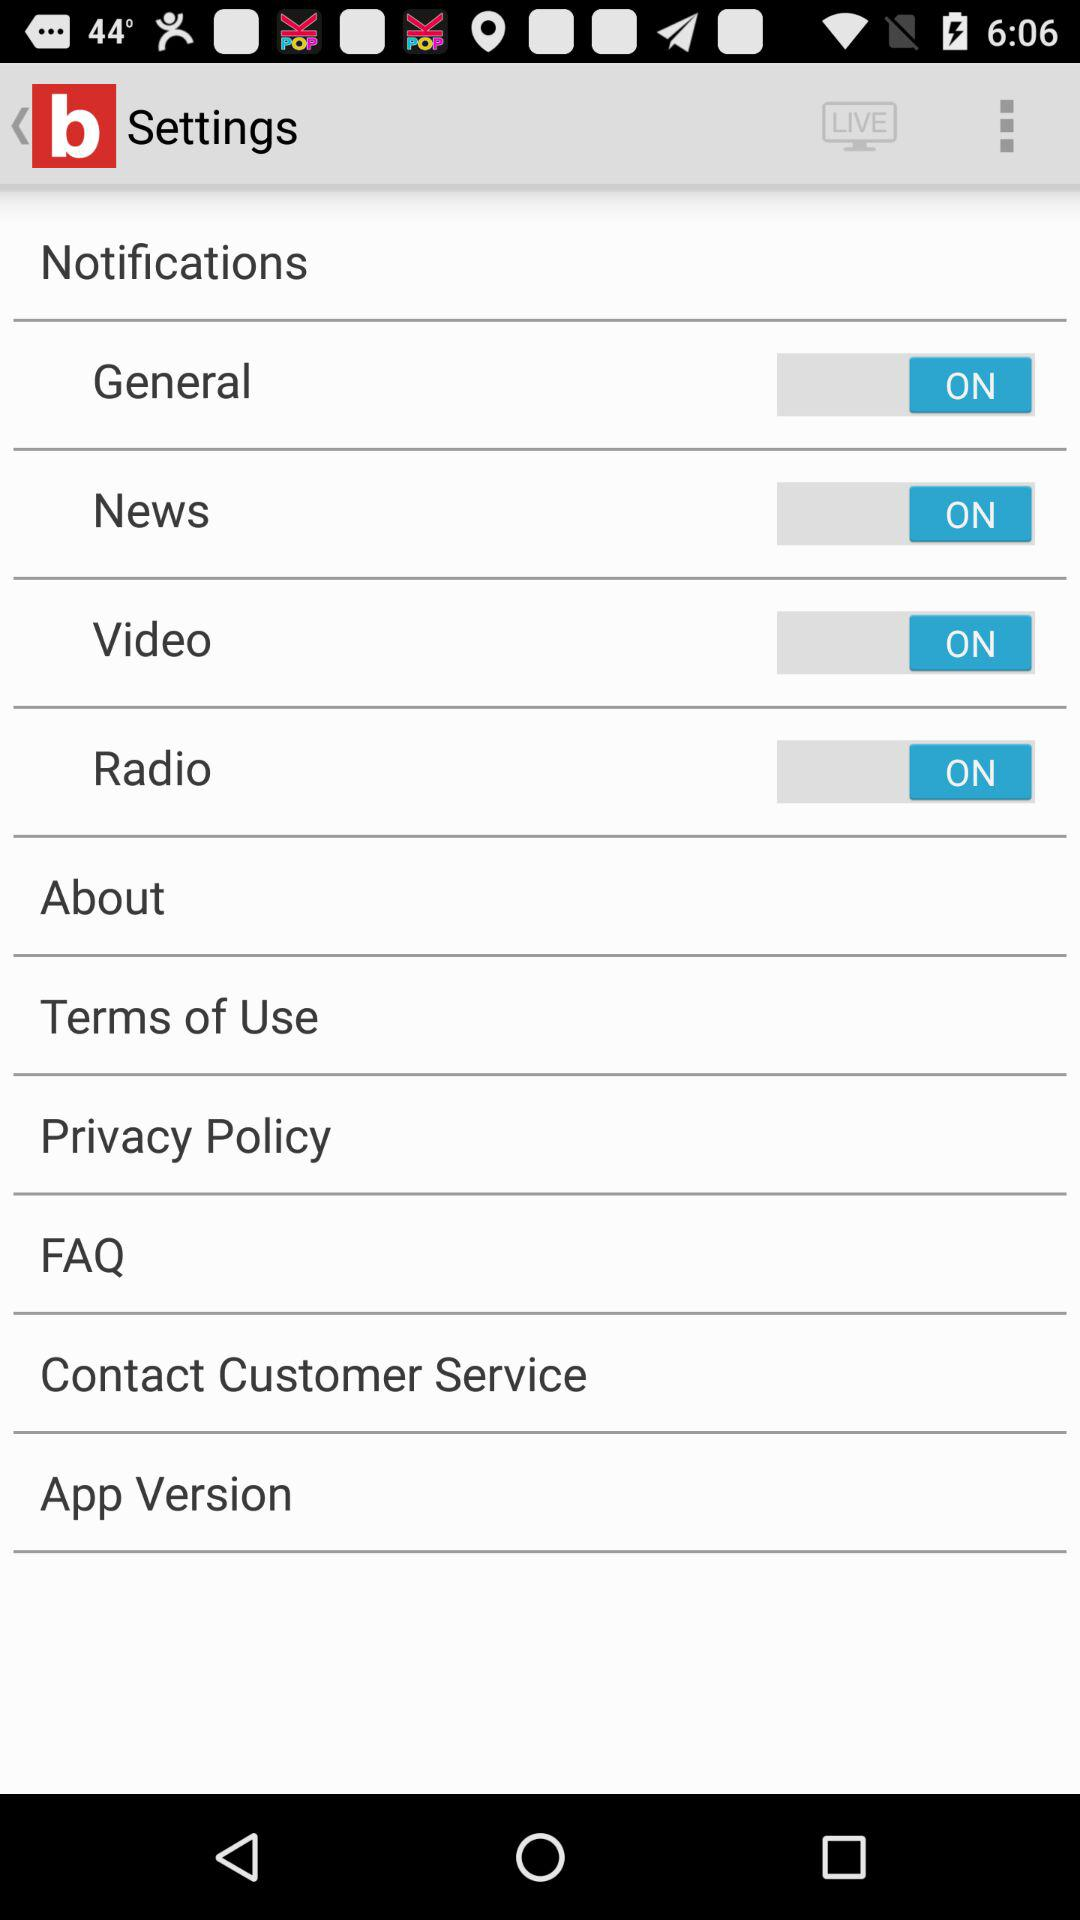What is the status of "News" notification setting? The status is "on". 